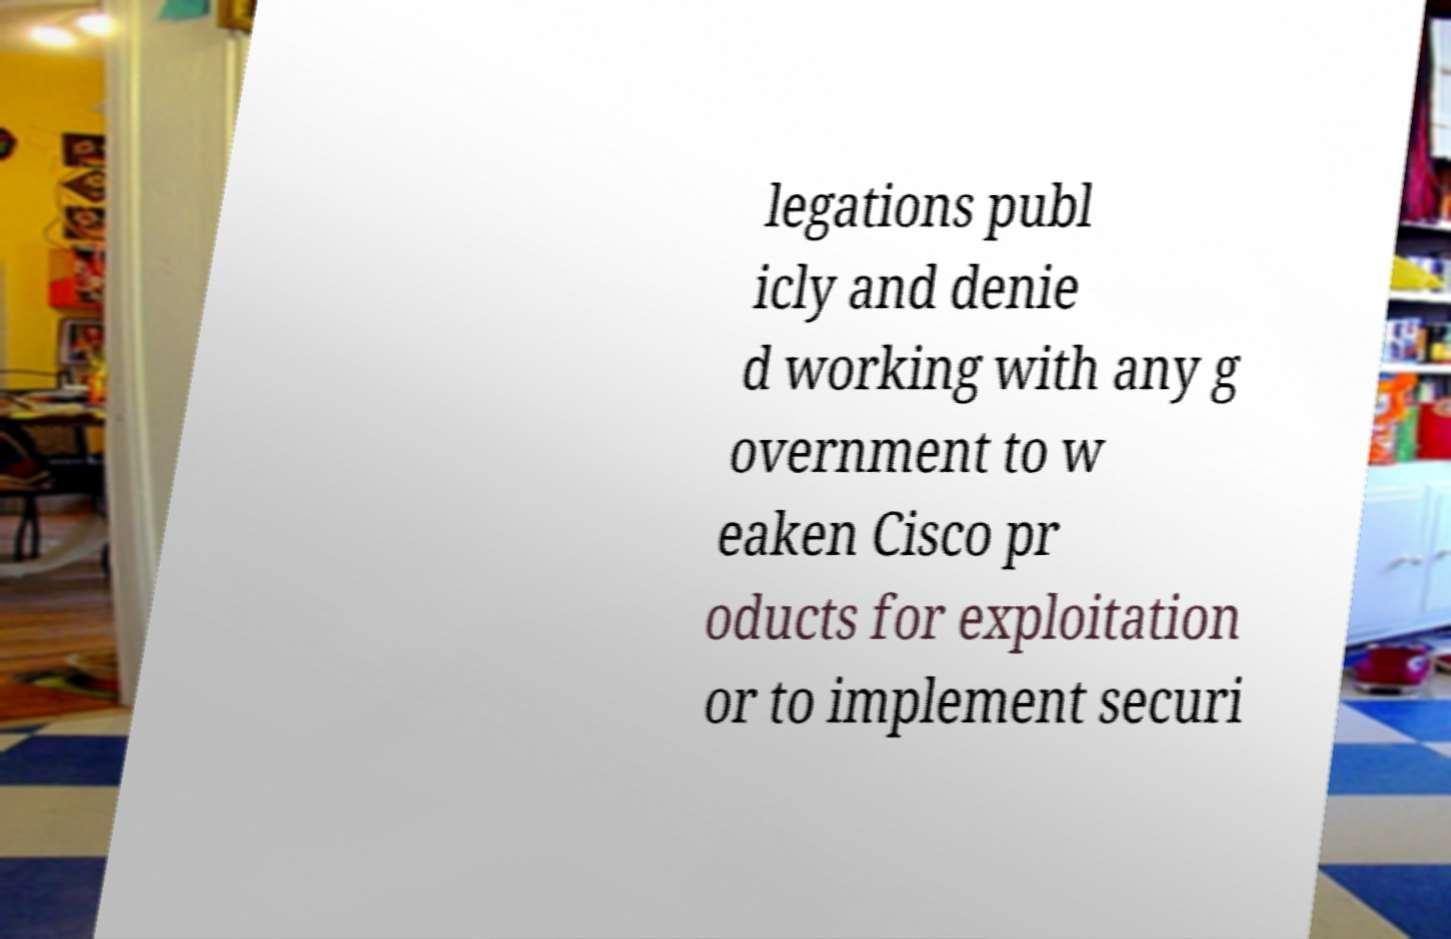There's text embedded in this image that I need extracted. Can you transcribe it verbatim? legations publ icly and denie d working with any g overnment to w eaken Cisco pr oducts for exploitation or to implement securi 